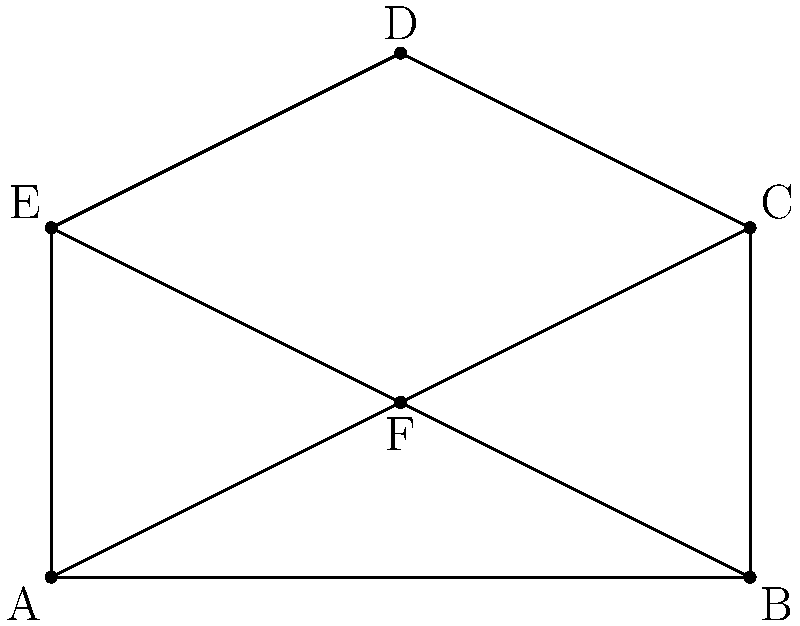In a serene garden, a butterfly-shaped flower bed is designed as shown in the figure. The garden is symmetrical along the line AF. If the area of triangle ABF is 4 square meters, what is the total area of the butterfly-shaped garden in square meters? Let's approach this step-by-step:

1) First, we note that the garden is symmetrical along line AF. This means that triangles ABF and AEF are congruent, as are triangles BCF and ECF.

2) We're given that the area of triangle ABF is 4 square meters.

3) Due to symmetry, the area of triangle AEF is also 4 square meters.

4) The total area of the lower part of the butterfly (quadrilateral ABEF) is thus $4 + 4 = 8$ square meters.

5) Now, let's consider the upper part. Triangles BCF and ECF together form a quadrilateral BCEF that is congruent to ABEF (due to symmetry).

6) Therefore, the area of the upper part (quadrilateral BCEF) is also 8 square meters.

7) The total area of the butterfly is the sum of the areas of the upper and lower parts:
   
   Total Area = Area of ABEF + Area of BCEF
               = $8 + 8 = 16$ square meters

Thus, the total area of the butterfly-shaped garden is 16 square meters.
Answer: 16 square meters 